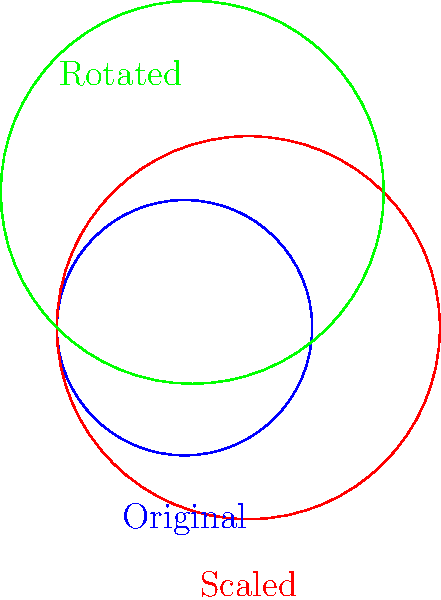A Viking knotwork pattern is scaled by a factor of 1.5 and then rotated 45 degrees counterclockwise. If the original pattern had an area of 4 square units, what is the area of the final rotated pattern? Let's approach this step-by-step:

1. Original area: 4 square units

2. Scaling:
   When a shape is scaled by a factor of $k$, its area is multiplied by $k^2$.
   Scale factor = 1.5
   New area = Original area × $1.5^2$
   New area = $4 \times 1.5^2 = 4 \times 2.25 = 9$ square units

3. Rotation:
   Rotation doesn't change the area of a shape, it only changes its orientation.

Therefore, the area of the final rotated pattern remains 9 square units.
Answer: 9 square units 